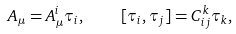Convert formula to latex. <formula><loc_0><loc_0><loc_500><loc_500>A _ { \mu } = A _ { \mu } ^ { i } \tau _ { i } , \quad [ \tau _ { i } , \tau _ { j } ] = C _ { i j } ^ { k } \tau _ { k } ,</formula> 